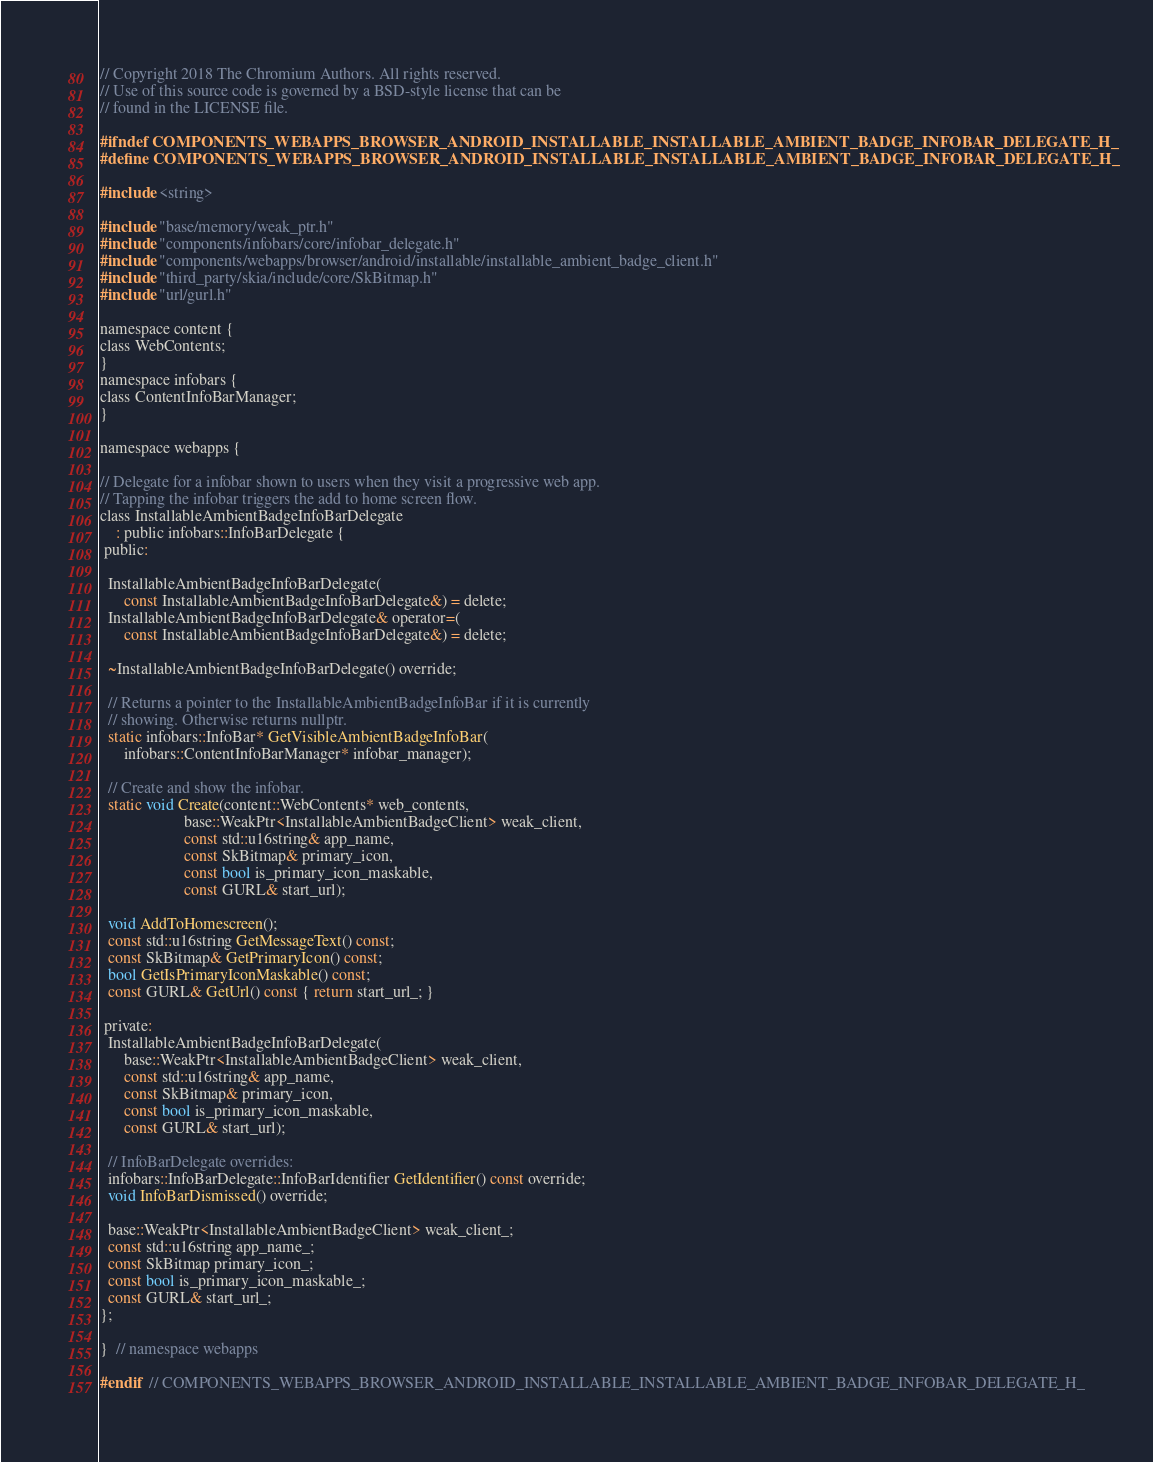<code> <loc_0><loc_0><loc_500><loc_500><_C_>// Copyright 2018 The Chromium Authors. All rights reserved.
// Use of this source code is governed by a BSD-style license that can be
// found in the LICENSE file.

#ifndef COMPONENTS_WEBAPPS_BROWSER_ANDROID_INSTALLABLE_INSTALLABLE_AMBIENT_BADGE_INFOBAR_DELEGATE_H_
#define COMPONENTS_WEBAPPS_BROWSER_ANDROID_INSTALLABLE_INSTALLABLE_AMBIENT_BADGE_INFOBAR_DELEGATE_H_

#include <string>

#include "base/memory/weak_ptr.h"
#include "components/infobars/core/infobar_delegate.h"
#include "components/webapps/browser/android/installable/installable_ambient_badge_client.h"
#include "third_party/skia/include/core/SkBitmap.h"
#include "url/gurl.h"

namespace content {
class WebContents;
}
namespace infobars {
class ContentInfoBarManager;
}

namespace webapps {

// Delegate for a infobar shown to users when they visit a progressive web app.
// Tapping the infobar triggers the add to home screen flow.
class InstallableAmbientBadgeInfoBarDelegate
    : public infobars::InfoBarDelegate {
 public:

  InstallableAmbientBadgeInfoBarDelegate(
      const InstallableAmbientBadgeInfoBarDelegate&) = delete;
  InstallableAmbientBadgeInfoBarDelegate& operator=(
      const InstallableAmbientBadgeInfoBarDelegate&) = delete;

  ~InstallableAmbientBadgeInfoBarDelegate() override;

  // Returns a pointer to the InstallableAmbientBadgeInfoBar if it is currently
  // showing. Otherwise returns nullptr.
  static infobars::InfoBar* GetVisibleAmbientBadgeInfoBar(
      infobars::ContentInfoBarManager* infobar_manager);

  // Create and show the infobar.
  static void Create(content::WebContents* web_contents,
                     base::WeakPtr<InstallableAmbientBadgeClient> weak_client,
                     const std::u16string& app_name,
                     const SkBitmap& primary_icon,
                     const bool is_primary_icon_maskable,
                     const GURL& start_url);

  void AddToHomescreen();
  const std::u16string GetMessageText() const;
  const SkBitmap& GetPrimaryIcon() const;
  bool GetIsPrimaryIconMaskable() const;
  const GURL& GetUrl() const { return start_url_; }

 private:
  InstallableAmbientBadgeInfoBarDelegate(
      base::WeakPtr<InstallableAmbientBadgeClient> weak_client,
      const std::u16string& app_name,
      const SkBitmap& primary_icon,
      const bool is_primary_icon_maskable,
      const GURL& start_url);

  // InfoBarDelegate overrides:
  infobars::InfoBarDelegate::InfoBarIdentifier GetIdentifier() const override;
  void InfoBarDismissed() override;

  base::WeakPtr<InstallableAmbientBadgeClient> weak_client_;
  const std::u16string app_name_;
  const SkBitmap primary_icon_;
  const bool is_primary_icon_maskable_;
  const GURL& start_url_;
};

}  // namespace webapps

#endif  // COMPONENTS_WEBAPPS_BROWSER_ANDROID_INSTALLABLE_INSTALLABLE_AMBIENT_BADGE_INFOBAR_DELEGATE_H_
</code> 